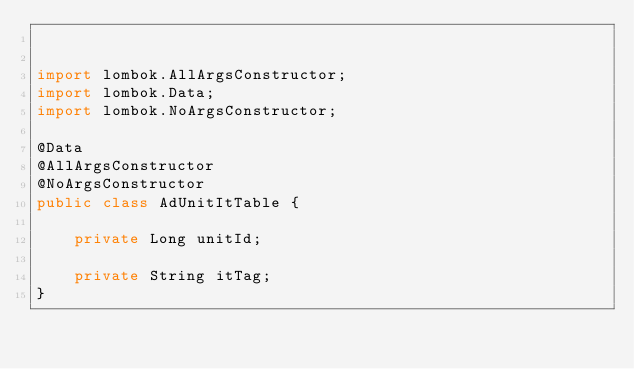Convert code to text. <code><loc_0><loc_0><loc_500><loc_500><_Java_>

import lombok.AllArgsConstructor;
import lombok.Data;
import lombok.NoArgsConstructor;

@Data
@AllArgsConstructor
@NoArgsConstructor
public class AdUnitItTable {

    private Long unitId;

    private String itTag;
}
</code> 